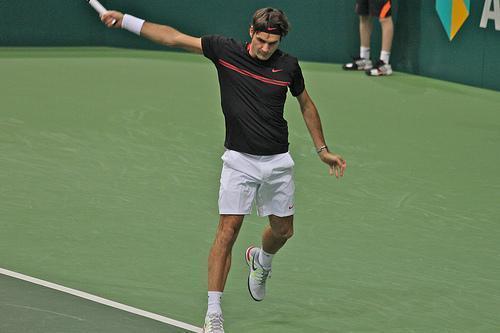How many shoes are in the photo?
Give a very brief answer. 4. How many players are here?
Give a very brief answer. 1. 